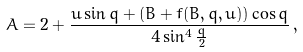Convert formula to latex. <formula><loc_0><loc_0><loc_500><loc_500>A = 2 + \frac { u \sin q + ( B + f ( B , q , u ) ) \cos q } { 4 \sin ^ { 4 } \frac { q } { 2 } } \, ,</formula> 